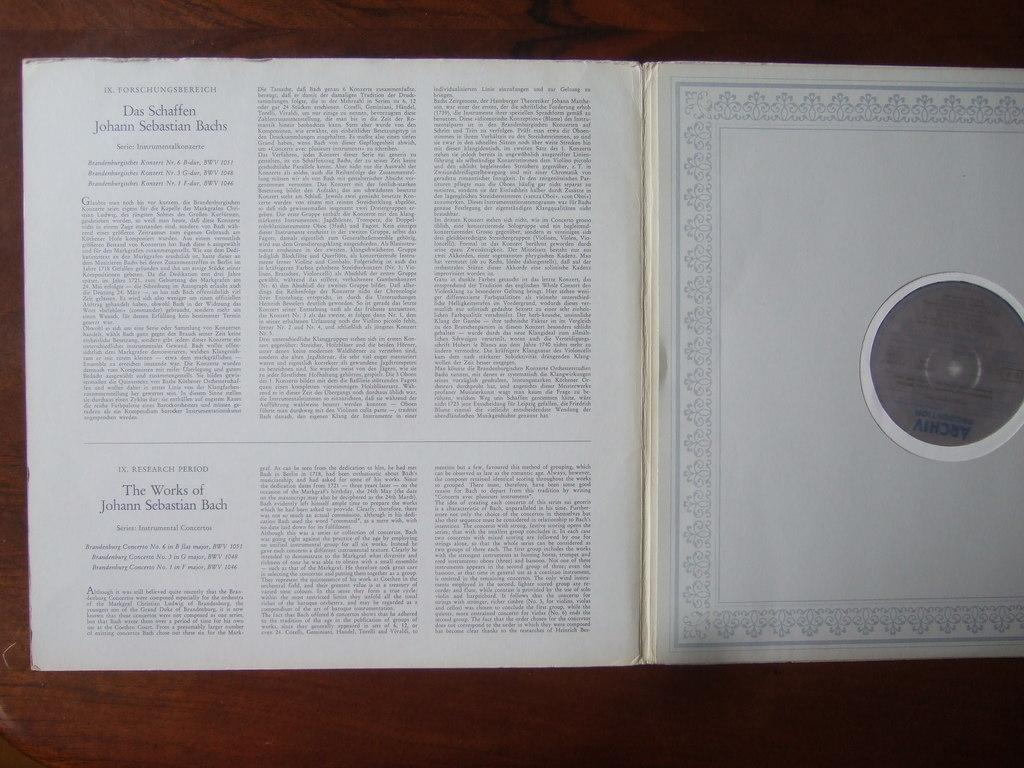<image>
Write a terse but informative summary of the picture. A record sleeve explaining the works of Johann Sebastian Bach. 